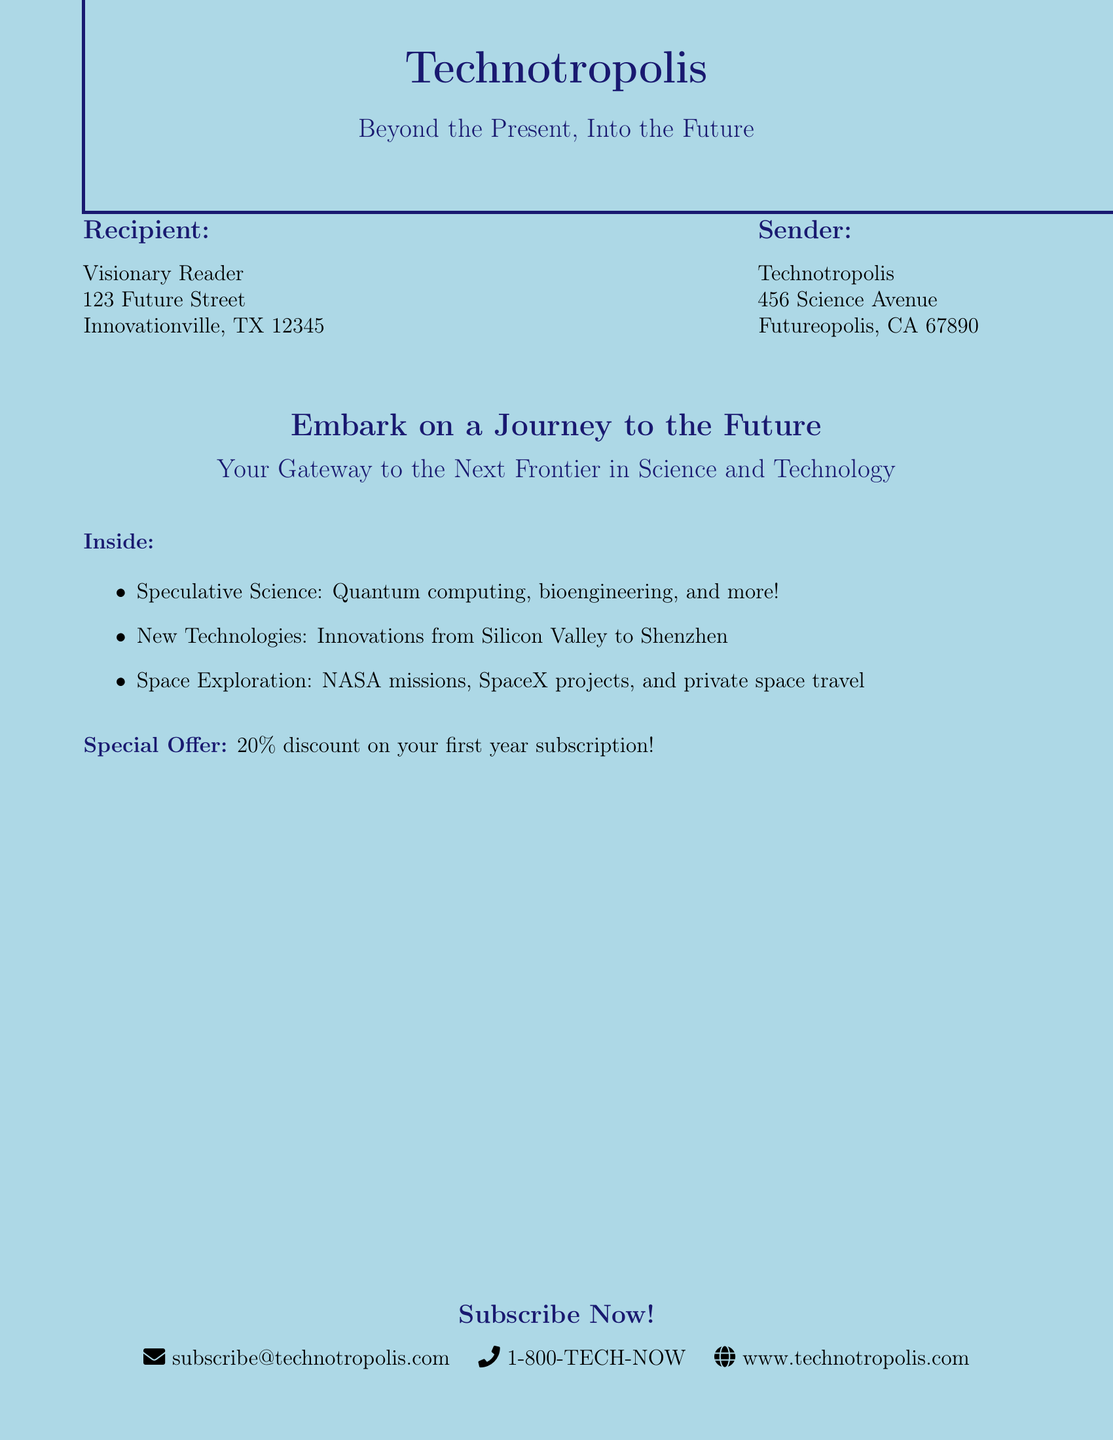What is the name of the journal? The document invites readers to subscribe to a journal named Technotropolis.
Answer: Technotropolis What is the special offer mentioned? The document states a special offer for a discount on the first year subscription.
Answer: 20% discount Where is the recipient located? The recipient's address includes Future Street, Innovationville, TX.
Answer: 123 Future Street, Innovationville, TX 12345 What type of content does the journal focus on? The content focuses on speculative science, new technologies, and space exploration.
Answer: Speculative science, new technologies, space exploration What is the contact email provided for subscriptions? The email for subscriptions is listed in the document under contact information.
Answer: subscribe@technotropolis.com What is the phone number to contact for subscriptions? The phone number provided in the document is available for readers to reach out for subscriptions.
Answer: 1-800-TECH-NOW What advantage does subscribing offer? The invitation highlights subscribing as a gateway to advancements in science.
Answer: Gateway to the Next Frontier in Science and Technology What is the address of the sender? The sender is located on Science Avenue in Futureopolis, CA.
Answer: 456 Science Avenue, Futureopolis, CA 67890 